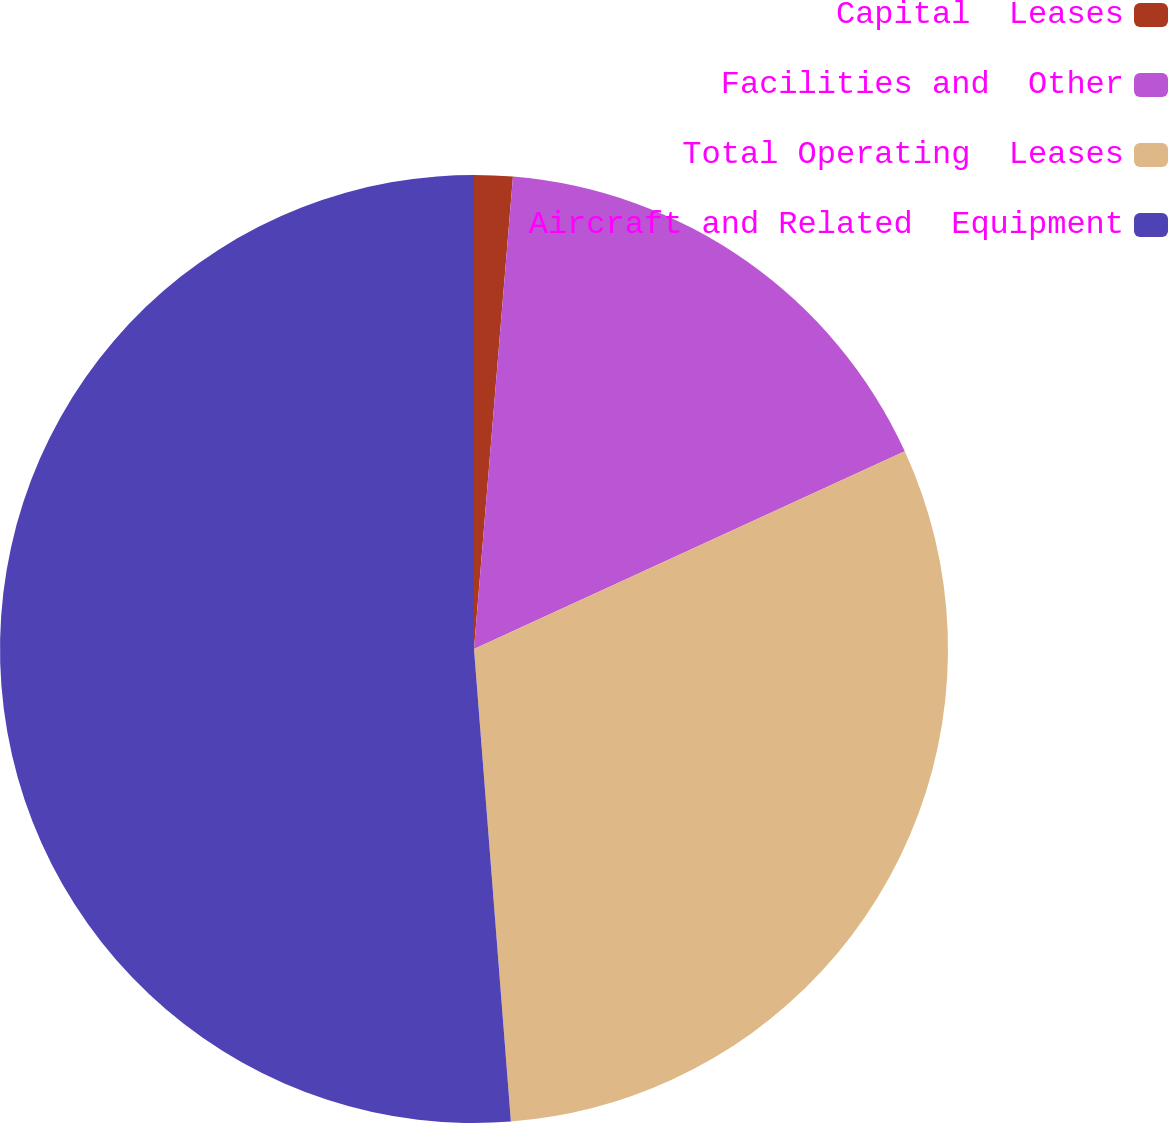Convert chart. <chart><loc_0><loc_0><loc_500><loc_500><pie_chart><fcel>Capital  Leases<fcel>Facilities and  Other<fcel>Total Operating  Leases<fcel>Aircraft and Related  Equipment<nl><fcel>1.31%<fcel>16.84%<fcel>30.61%<fcel>51.24%<nl></chart> 